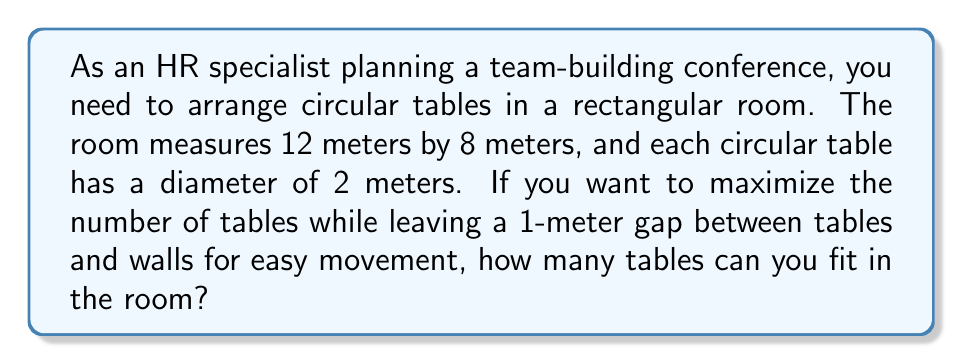Could you help me with this problem? Let's approach this step-by-step:

1) First, we need to calculate the effective area where tables can be placed:
   - Length: 12m - 2m (for gaps) = 10m
   - Width: 8m - 2m (for gaps) = 6m
   - Effective area: $10m \times 6m = 60m^2$

2) Each table occupies a square space:
   - Table diameter: 2m
   - Space between tables: 1m
   - Total space per table: $3m \times 3m = 9m^2$

3) We can calculate the maximum number of tables by dividing the effective area by the space per table:
   $$ \text{Number of tables} = \frac{\text{Effective area}}{\text{Space per table}} = \frac{60m^2}{9m^2} = 6.67 $$

4) Since we can't have a fractional number of tables, we round down to 6 tables.

5) Let's verify if 6 tables fit:
   - In length: $3m \times 3 = 9m$ (fits in 10m)
   - In width: $3m \times 2 = 6m$ (fits in 6m)

6) Arrangement: 3 tables in length, 2 tables in width

[asy]
unitsize(20);
draw((0,0)--(10,0)--(10,6)--(0,6)--cycle);
for(int i=0; i<3; ++i)
  for(int j=0; j<2; ++j)
    draw(circle((1.5+3*i,1.5+3*j),1));
[/asy]

This arrangement fits perfectly in the effective area while maintaining the required gaps.
Answer: 6 tables 